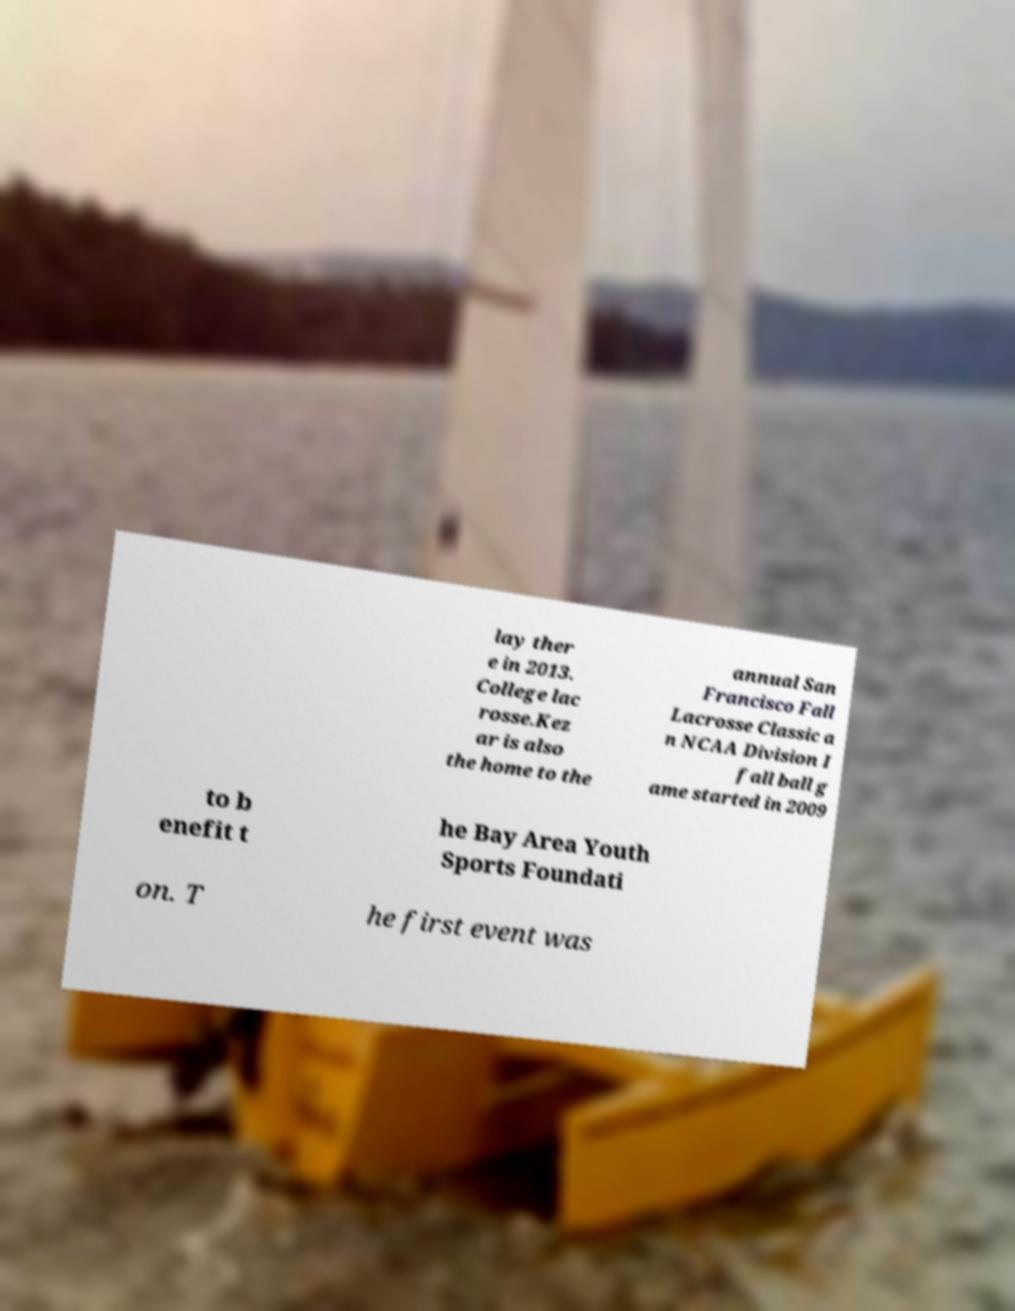Please identify and transcribe the text found in this image. lay ther e in 2013. College lac rosse.Kez ar is also the home to the annual San Francisco Fall Lacrosse Classic a n NCAA Division I fall ball g ame started in 2009 to b enefit t he Bay Area Youth Sports Foundati on. T he first event was 